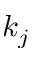<formula> <loc_0><loc_0><loc_500><loc_500>k _ { j }</formula> 